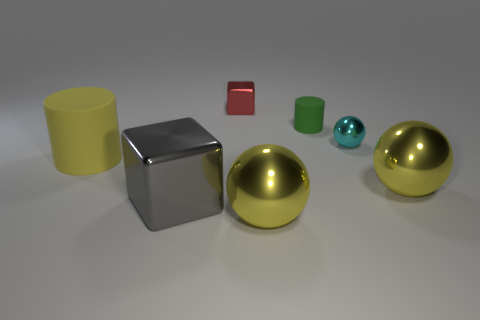Are there any blue objects that have the same size as the yellow rubber cylinder?
Make the answer very short. No. The gray block has what size?
Offer a terse response. Large. There is a yellow sphere to the left of the matte cylinder right of the metallic block behind the large yellow matte cylinder; what is it made of?
Give a very brief answer. Metal. Are there any other things that have the same shape as the small green object?
Provide a short and direct response. Yes. There is another matte thing that is the same shape as the big yellow matte object; what is its color?
Provide a succinct answer. Green. Does the metallic cube that is in front of the small cyan object have the same color as the rubber cylinder that is behind the small cyan thing?
Provide a short and direct response. No. Are there more green matte cylinders that are in front of the large gray metallic thing than yellow cylinders?
Offer a terse response. No. What number of other things are there of the same size as the green matte object?
Your response must be concise. 2. How many rubber cylinders are right of the gray shiny cube and to the left of the green object?
Ensure brevity in your answer.  0. Is the material of the large sphere in front of the large gray cube the same as the large cylinder?
Your answer should be compact. No. 